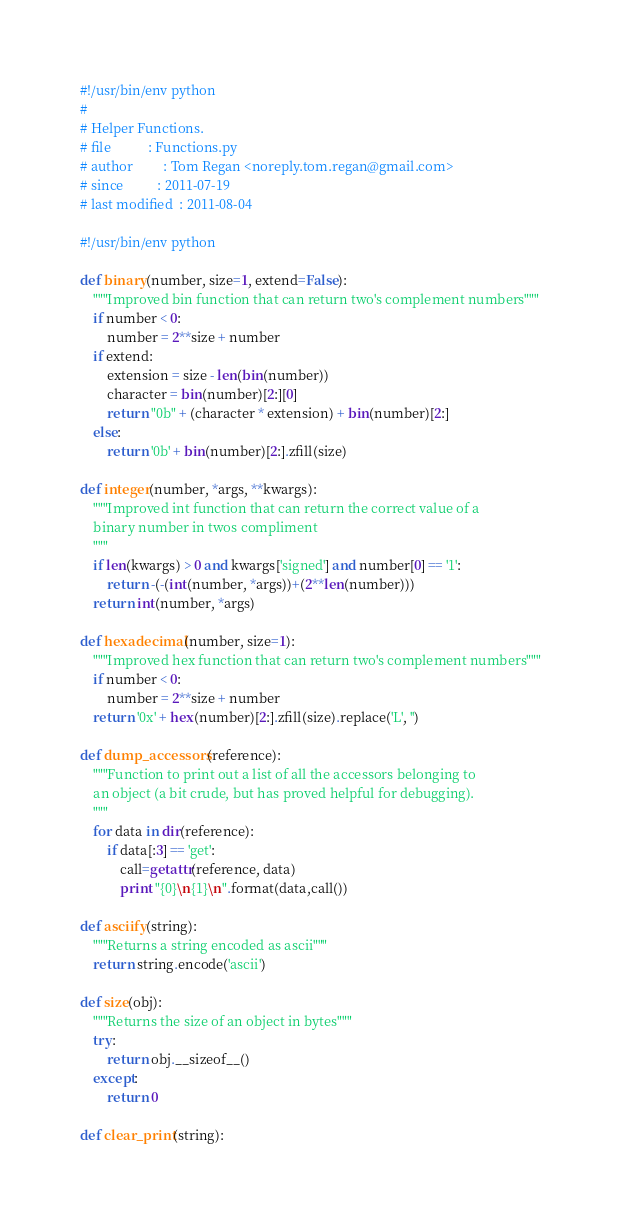<code> <loc_0><loc_0><loc_500><loc_500><_Python_>#!/usr/bin/env python
#
# Helper Functions.
# file           : Functions.py
# author         : Tom Regan <noreply.tom.regan@gmail.com>
# since          : 2011-07-19
# last modified  : 2011-08-04

#!/usr/bin/env python

def binary(number, size=1, extend=False):
    """Improved bin function that can return two's complement numbers"""
    if number < 0:
        number = 2**size + number
    if extend:
        extension = size - len(bin(number))
        character = bin(number)[2:][0]
        return "0b" + (character * extension) + bin(number)[2:]
    else:
        return '0b' + bin(number)[2:].zfill(size)

def integer(number, *args, **kwargs):
    """Improved int function that can return the correct value of a
    binary number in twos compliment
    """
    if len(kwargs) > 0 and kwargs['signed'] and number[0] == '1':
        return -(-(int(number, *args))+(2**len(number)))
    return int(number, *args)

def hexadecimal(number, size=1):
    """Improved hex function that can return two's complement numbers"""
    if number < 0:
        number = 2**size + number
    return '0x' + hex(number)[2:].zfill(size).replace('L', '')

def dump_accessors(reference):
    """Function to print out a list of all the accessors belonging to
    an object (a bit crude, but has proved helpful for debugging).
    """
    for data in dir(reference):
        if data[:3] == 'get':
            call=getattr(reference, data)
            print "{0}\n{1}\n".format(data,call())

def asciify(string):
    """Returns a string encoded as ascii"""
    return string.encode('ascii')

def size(obj):
    """Returns the size of an object in bytes"""
    try:
        return obj.__sizeof__()
    except:
        return 0

def clear_print(string):</code> 